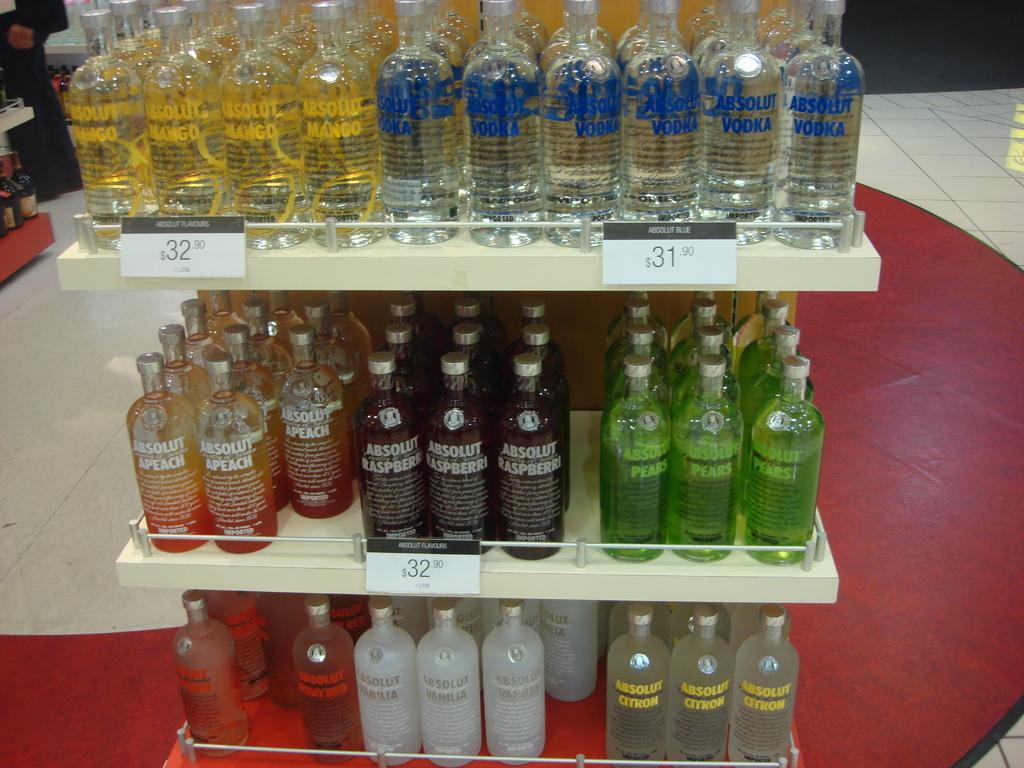<image>
Give a short and clear explanation of the subsequent image. Several shelves filled with bottles of Absolut Vodka 